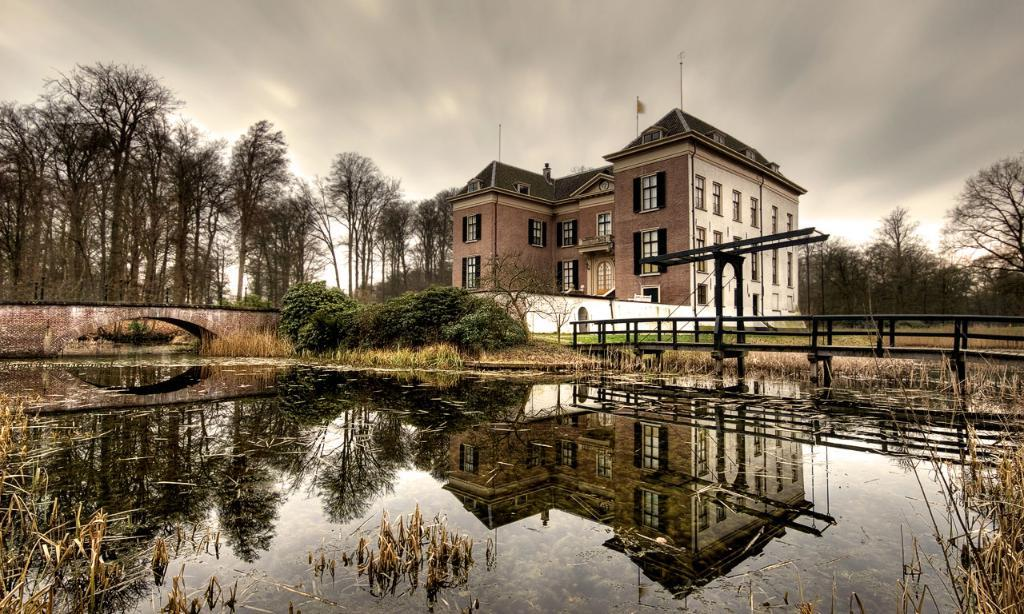What structure can be seen in the right corner of the image? There is a bridge in the right corner of the image. What is under the bridge? There is water under the bridge. What can be seen in the background of the image? There is a building and trees in the background of the image. How many ants are crawling on the bridge in the image? There are no ants present in the image. What type of books can be found in the library depicted in the image? There is no library depicted in the image. 